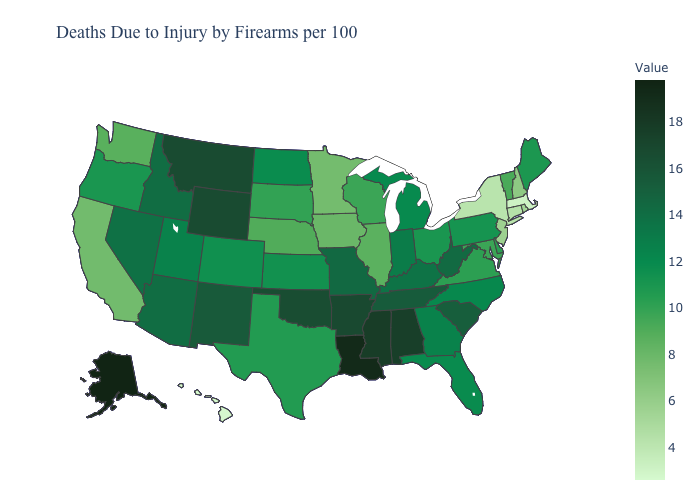Among the states that border California , does Nevada have the lowest value?
Be succinct. No. Does Washington have the highest value in the USA?
Give a very brief answer. No. Does Missouri have the highest value in the MidWest?
Write a very short answer. Yes. Which states have the lowest value in the MidWest?
Answer briefly. Minnesota. Among the states that border Georgia , which have the lowest value?
Quick response, please. Florida. Which states have the lowest value in the USA?
Short answer required. Hawaii. 